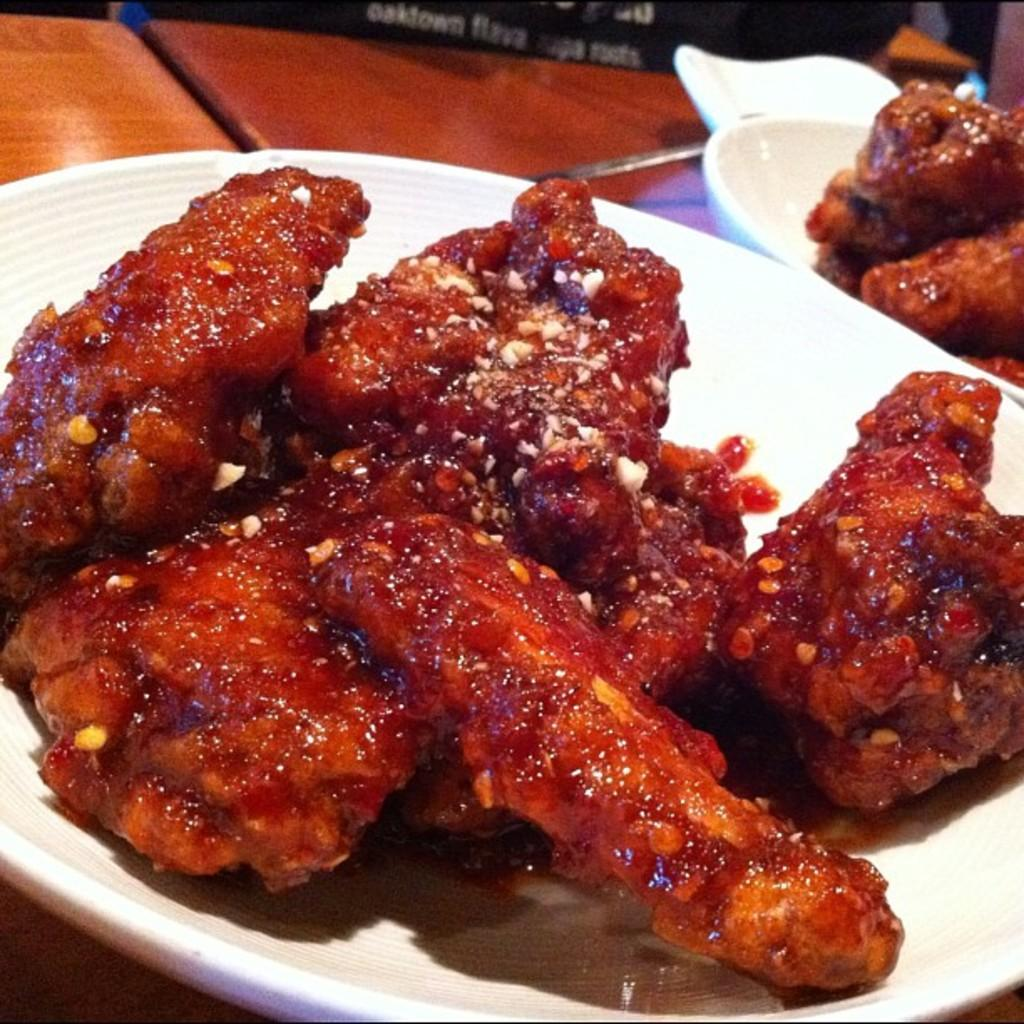What is in the bowls that are visible in the image? There are bowls containing food in the image. What utensils are visible in the image? Spoons are visible in the image. Where are the bowls and spoons located? The bowls and spoons are placed on a table. Can you describe the person in the background of the image? The provided facts do not give any information about the person in the background, so we cannot describe them. What type of canvas is being used to paint the box in the image? There is no canvas, box, or painting present in the image. 